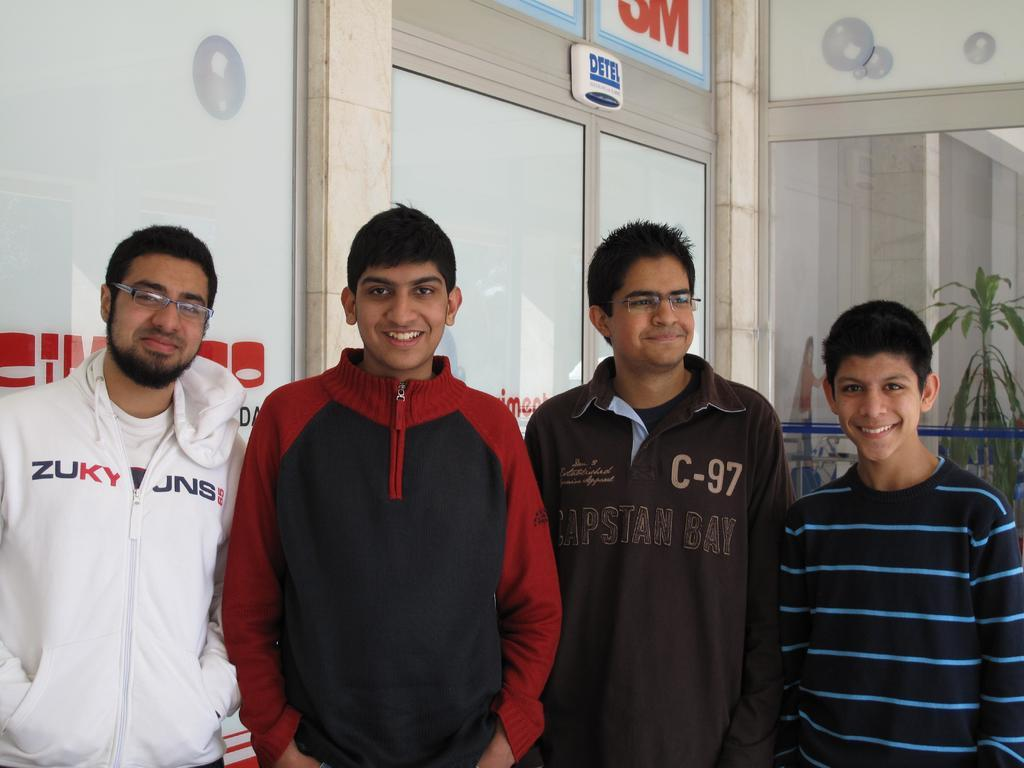<image>
Relay a brief, clear account of the picture shown. Four young men are standing by a double door and one of their sweatshirts says Capstan Bay. 